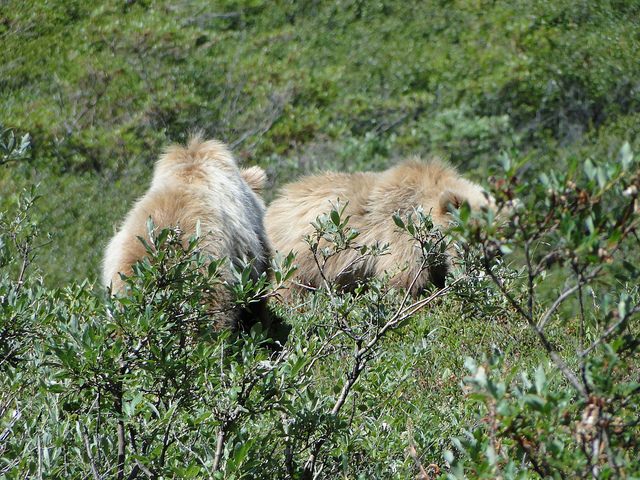Can you tell me what type of habitat this is? The image shows a natural habitat with dense, low-lying vegetation, which suggests a shrubland or brush area, possibly part of a larger forest or wilderness. 